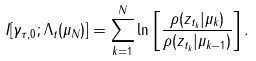<formula> <loc_0><loc_0><loc_500><loc_500>I [ \gamma _ { \tau , 0 } ; \Lambda _ { t } ( \mu _ { N } ) ] = \sum _ { k = 1 } ^ { N } \ln \left [ \frac { \rho ( z _ { t _ { k } } | \mu _ { k } ) } { \rho ( z _ { t _ { k } } | \mu _ { k - 1 } ) } \right ] .</formula> 